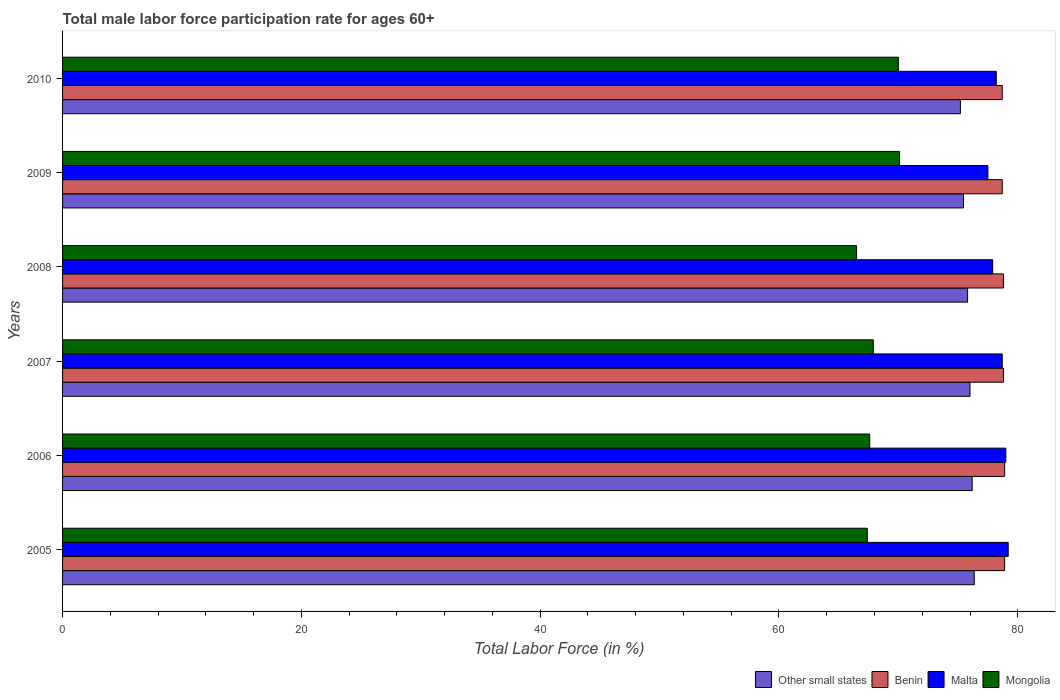How many groups of bars are there?
Provide a succinct answer. 6. Are the number of bars per tick equal to the number of legend labels?
Provide a short and direct response. Yes. What is the label of the 2nd group of bars from the top?
Your response must be concise. 2009. What is the male labor force participation rate in Malta in 2006?
Give a very brief answer. 79. Across all years, what is the maximum male labor force participation rate in Other small states?
Provide a succinct answer. 76.35. Across all years, what is the minimum male labor force participation rate in Other small states?
Provide a short and direct response. 75.2. What is the total male labor force participation rate in Mongolia in the graph?
Offer a terse response. 409.5. What is the difference between the male labor force participation rate in Benin in 2006 and that in 2010?
Offer a terse response. 0.2. What is the difference between the male labor force participation rate in Malta in 2006 and the male labor force participation rate in Mongolia in 2009?
Your answer should be very brief. 8.9. What is the average male labor force participation rate in Other small states per year?
Provide a succinct answer. 75.83. In the year 2005, what is the difference between the male labor force participation rate in Benin and male labor force participation rate in Malta?
Provide a succinct answer. -0.3. What is the ratio of the male labor force participation rate in Other small states in 2009 to that in 2010?
Make the answer very short. 1. Is the male labor force participation rate in Mongolia in 2007 less than that in 2010?
Offer a terse response. Yes. What is the difference between the highest and the second highest male labor force participation rate in Benin?
Offer a very short reply. 0. What is the difference between the highest and the lowest male labor force participation rate in Other small states?
Offer a terse response. 1.16. In how many years, is the male labor force participation rate in Mongolia greater than the average male labor force participation rate in Mongolia taken over all years?
Give a very brief answer. 2. Is the sum of the male labor force participation rate in Other small states in 2005 and 2010 greater than the maximum male labor force participation rate in Benin across all years?
Offer a terse response. Yes. What does the 2nd bar from the top in 2005 represents?
Ensure brevity in your answer.  Malta. What does the 1st bar from the bottom in 2010 represents?
Your answer should be compact. Other small states. Is it the case that in every year, the sum of the male labor force participation rate in Mongolia and male labor force participation rate in Other small states is greater than the male labor force participation rate in Malta?
Provide a short and direct response. Yes. Are all the bars in the graph horizontal?
Keep it short and to the point. Yes. What is the difference between two consecutive major ticks on the X-axis?
Your answer should be compact. 20. How many legend labels are there?
Your response must be concise. 4. What is the title of the graph?
Give a very brief answer. Total male labor force participation rate for ages 60+. Does "Romania" appear as one of the legend labels in the graph?
Offer a very short reply. No. What is the label or title of the Y-axis?
Your answer should be compact. Years. What is the Total Labor Force (in %) of Other small states in 2005?
Your answer should be very brief. 76.35. What is the Total Labor Force (in %) in Benin in 2005?
Offer a terse response. 78.9. What is the Total Labor Force (in %) in Malta in 2005?
Make the answer very short. 79.2. What is the Total Labor Force (in %) in Mongolia in 2005?
Offer a terse response. 67.4. What is the Total Labor Force (in %) in Other small states in 2006?
Make the answer very short. 76.18. What is the Total Labor Force (in %) of Benin in 2006?
Your response must be concise. 78.9. What is the Total Labor Force (in %) of Malta in 2006?
Offer a very short reply. 79. What is the Total Labor Force (in %) in Mongolia in 2006?
Your answer should be compact. 67.6. What is the Total Labor Force (in %) of Other small states in 2007?
Provide a succinct answer. 76. What is the Total Labor Force (in %) of Benin in 2007?
Offer a very short reply. 78.8. What is the Total Labor Force (in %) in Malta in 2007?
Your answer should be very brief. 78.7. What is the Total Labor Force (in %) of Mongolia in 2007?
Ensure brevity in your answer.  67.9. What is the Total Labor Force (in %) of Other small states in 2008?
Ensure brevity in your answer.  75.8. What is the Total Labor Force (in %) in Benin in 2008?
Offer a very short reply. 78.8. What is the Total Labor Force (in %) in Malta in 2008?
Offer a very short reply. 77.9. What is the Total Labor Force (in %) of Mongolia in 2008?
Ensure brevity in your answer.  66.5. What is the Total Labor Force (in %) of Other small states in 2009?
Offer a terse response. 75.46. What is the Total Labor Force (in %) of Benin in 2009?
Your answer should be very brief. 78.7. What is the Total Labor Force (in %) in Malta in 2009?
Your answer should be compact. 77.5. What is the Total Labor Force (in %) of Mongolia in 2009?
Ensure brevity in your answer.  70.1. What is the Total Labor Force (in %) of Other small states in 2010?
Your response must be concise. 75.2. What is the Total Labor Force (in %) of Benin in 2010?
Provide a short and direct response. 78.7. What is the Total Labor Force (in %) of Malta in 2010?
Your answer should be very brief. 78.2. Across all years, what is the maximum Total Labor Force (in %) of Other small states?
Provide a short and direct response. 76.35. Across all years, what is the maximum Total Labor Force (in %) of Benin?
Offer a very short reply. 78.9. Across all years, what is the maximum Total Labor Force (in %) of Malta?
Ensure brevity in your answer.  79.2. Across all years, what is the maximum Total Labor Force (in %) of Mongolia?
Make the answer very short. 70.1. Across all years, what is the minimum Total Labor Force (in %) in Other small states?
Provide a short and direct response. 75.2. Across all years, what is the minimum Total Labor Force (in %) in Benin?
Give a very brief answer. 78.7. Across all years, what is the minimum Total Labor Force (in %) of Malta?
Provide a succinct answer. 77.5. Across all years, what is the minimum Total Labor Force (in %) of Mongolia?
Make the answer very short. 66.5. What is the total Total Labor Force (in %) of Other small states in the graph?
Provide a short and direct response. 454.99. What is the total Total Labor Force (in %) of Benin in the graph?
Make the answer very short. 472.8. What is the total Total Labor Force (in %) of Malta in the graph?
Make the answer very short. 470.5. What is the total Total Labor Force (in %) in Mongolia in the graph?
Keep it short and to the point. 409.5. What is the difference between the Total Labor Force (in %) of Other small states in 2005 and that in 2006?
Offer a terse response. 0.17. What is the difference between the Total Labor Force (in %) in Benin in 2005 and that in 2006?
Keep it short and to the point. 0. What is the difference between the Total Labor Force (in %) in Malta in 2005 and that in 2006?
Keep it short and to the point. 0.2. What is the difference between the Total Labor Force (in %) in Other small states in 2005 and that in 2007?
Offer a very short reply. 0.35. What is the difference between the Total Labor Force (in %) in Benin in 2005 and that in 2007?
Give a very brief answer. 0.1. What is the difference between the Total Labor Force (in %) of Mongolia in 2005 and that in 2007?
Provide a succinct answer. -0.5. What is the difference between the Total Labor Force (in %) in Other small states in 2005 and that in 2008?
Offer a very short reply. 0.56. What is the difference between the Total Labor Force (in %) of Mongolia in 2005 and that in 2008?
Give a very brief answer. 0.9. What is the difference between the Total Labor Force (in %) of Other small states in 2005 and that in 2009?
Make the answer very short. 0.9. What is the difference between the Total Labor Force (in %) in Mongolia in 2005 and that in 2009?
Give a very brief answer. -2.7. What is the difference between the Total Labor Force (in %) in Other small states in 2005 and that in 2010?
Give a very brief answer. 1.16. What is the difference between the Total Labor Force (in %) of Benin in 2005 and that in 2010?
Make the answer very short. 0.2. What is the difference between the Total Labor Force (in %) of Malta in 2005 and that in 2010?
Provide a short and direct response. 1. What is the difference between the Total Labor Force (in %) of Other small states in 2006 and that in 2007?
Make the answer very short. 0.18. What is the difference between the Total Labor Force (in %) in Benin in 2006 and that in 2007?
Give a very brief answer. 0.1. What is the difference between the Total Labor Force (in %) in Mongolia in 2006 and that in 2007?
Keep it short and to the point. -0.3. What is the difference between the Total Labor Force (in %) in Other small states in 2006 and that in 2008?
Make the answer very short. 0.38. What is the difference between the Total Labor Force (in %) in Malta in 2006 and that in 2008?
Your response must be concise. 1.1. What is the difference between the Total Labor Force (in %) of Other small states in 2006 and that in 2009?
Keep it short and to the point. 0.73. What is the difference between the Total Labor Force (in %) in Benin in 2006 and that in 2009?
Provide a succinct answer. 0.2. What is the difference between the Total Labor Force (in %) of Mongolia in 2006 and that in 2009?
Provide a short and direct response. -2.5. What is the difference between the Total Labor Force (in %) in Other small states in 2006 and that in 2010?
Provide a short and direct response. 0.99. What is the difference between the Total Labor Force (in %) in Benin in 2006 and that in 2010?
Your answer should be very brief. 0.2. What is the difference between the Total Labor Force (in %) in Malta in 2006 and that in 2010?
Give a very brief answer. 0.8. What is the difference between the Total Labor Force (in %) of Other small states in 2007 and that in 2008?
Keep it short and to the point. 0.2. What is the difference between the Total Labor Force (in %) in Benin in 2007 and that in 2008?
Your answer should be compact. 0. What is the difference between the Total Labor Force (in %) in Malta in 2007 and that in 2008?
Offer a very short reply. 0.8. What is the difference between the Total Labor Force (in %) of Mongolia in 2007 and that in 2008?
Your answer should be compact. 1.4. What is the difference between the Total Labor Force (in %) in Other small states in 2007 and that in 2009?
Your answer should be compact. 0.54. What is the difference between the Total Labor Force (in %) in Mongolia in 2007 and that in 2009?
Your answer should be very brief. -2.2. What is the difference between the Total Labor Force (in %) in Other small states in 2007 and that in 2010?
Provide a succinct answer. 0.8. What is the difference between the Total Labor Force (in %) in Benin in 2007 and that in 2010?
Provide a short and direct response. 0.1. What is the difference between the Total Labor Force (in %) in Mongolia in 2007 and that in 2010?
Your answer should be very brief. -2.1. What is the difference between the Total Labor Force (in %) in Other small states in 2008 and that in 2009?
Offer a terse response. 0.34. What is the difference between the Total Labor Force (in %) of Benin in 2008 and that in 2009?
Your answer should be very brief. 0.1. What is the difference between the Total Labor Force (in %) in Malta in 2008 and that in 2009?
Your answer should be very brief. 0.4. What is the difference between the Total Labor Force (in %) in Mongolia in 2008 and that in 2009?
Your answer should be compact. -3.6. What is the difference between the Total Labor Force (in %) in Other small states in 2008 and that in 2010?
Offer a very short reply. 0.6. What is the difference between the Total Labor Force (in %) in Benin in 2008 and that in 2010?
Make the answer very short. 0.1. What is the difference between the Total Labor Force (in %) in Mongolia in 2008 and that in 2010?
Your response must be concise. -3.5. What is the difference between the Total Labor Force (in %) in Other small states in 2009 and that in 2010?
Offer a very short reply. 0.26. What is the difference between the Total Labor Force (in %) of Benin in 2009 and that in 2010?
Keep it short and to the point. 0. What is the difference between the Total Labor Force (in %) in Malta in 2009 and that in 2010?
Provide a succinct answer. -0.7. What is the difference between the Total Labor Force (in %) of Other small states in 2005 and the Total Labor Force (in %) of Benin in 2006?
Provide a short and direct response. -2.55. What is the difference between the Total Labor Force (in %) in Other small states in 2005 and the Total Labor Force (in %) in Malta in 2006?
Your response must be concise. -2.65. What is the difference between the Total Labor Force (in %) in Other small states in 2005 and the Total Labor Force (in %) in Mongolia in 2006?
Make the answer very short. 8.75. What is the difference between the Total Labor Force (in %) in Benin in 2005 and the Total Labor Force (in %) in Malta in 2006?
Keep it short and to the point. -0.1. What is the difference between the Total Labor Force (in %) in Benin in 2005 and the Total Labor Force (in %) in Mongolia in 2006?
Provide a succinct answer. 11.3. What is the difference between the Total Labor Force (in %) in Malta in 2005 and the Total Labor Force (in %) in Mongolia in 2006?
Your answer should be very brief. 11.6. What is the difference between the Total Labor Force (in %) of Other small states in 2005 and the Total Labor Force (in %) of Benin in 2007?
Your response must be concise. -2.45. What is the difference between the Total Labor Force (in %) of Other small states in 2005 and the Total Labor Force (in %) of Malta in 2007?
Provide a short and direct response. -2.35. What is the difference between the Total Labor Force (in %) in Other small states in 2005 and the Total Labor Force (in %) in Mongolia in 2007?
Offer a terse response. 8.45. What is the difference between the Total Labor Force (in %) in Benin in 2005 and the Total Labor Force (in %) in Malta in 2007?
Offer a very short reply. 0.2. What is the difference between the Total Labor Force (in %) in Other small states in 2005 and the Total Labor Force (in %) in Benin in 2008?
Your answer should be compact. -2.45. What is the difference between the Total Labor Force (in %) of Other small states in 2005 and the Total Labor Force (in %) of Malta in 2008?
Provide a succinct answer. -1.55. What is the difference between the Total Labor Force (in %) of Other small states in 2005 and the Total Labor Force (in %) of Mongolia in 2008?
Provide a succinct answer. 9.85. What is the difference between the Total Labor Force (in %) in Benin in 2005 and the Total Labor Force (in %) in Malta in 2008?
Provide a succinct answer. 1. What is the difference between the Total Labor Force (in %) in Malta in 2005 and the Total Labor Force (in %) in Mongolia in 2008?
Provide a succinct answer. 12.7. What is the difference between the Total Labor Force (in %) of Other small states in 2005 and the Total Labor Force (in %) of Benin in 2009?
Your response must be concise. -2.35. What is the difference between the Total Labor Force (in %) in Other small states in 2005 and the Total Labor Force (in %) in Malta in 2009?
Make the answer very short. -1.15. What is the difference between the Total Labor Force (in %) of Other small states in 2005 and the Total Labor Force (in %) of Mongolia in 2009?
Provide a succinct answer. 6.25. What is the difference between the Total Labor Force (in %) of Benin in 2005 and the Total Labor Force (in %) of Malta in 2009?
Ensure brevity in your answer.  1.4. What is the difference between the Total Labor Force (in %) of Other small states in 2005 and the Total Labor Force (in %) of Benin in 2010?
Your answer should be very brief. -2.35. What is the difference between the Total Labor Force (in %) in Other small states in 2005 and the Total Labor Force (in %) in Malta in 2010?
Offer a very short reply. -1.85. What is the difference between the Total Labor Force (in %) of Other small states in 2005 and the Total Labor Force (in %) of Mongolia in 2010?
Keep it short and to the point. 6.35. What is the difference between the Total Labor Force (in %) in Benin in 2005 and the Total Labor Force (in %) in Malta in 2010?
Make the answer very short. 0.7. What is the difference between the Total Labor Force (in %) of Benin in 2005 and the Total Labor Force (in %) of Mongolia in 2010?
Provide a succinct answer. 8.9. What is the difference between the Total Labor Force (in %) in Other small states in 2006 and the Total Labor Force (in %) in Benin in 2007?
Offer a terse response. -2.62. What is the difference between the Total Labor Force (in %) of Other small states in 2006 and the Total Labor Force (in %) of Malta in 2007?
Offer a very short reply. -2.52. What is the difference between the Total Labor Force (in %) in Other small states in 2006 and the Total Labor Force (in %) in Mongolia in 2007?
Your answer should be very brief. 8.28. What is the difference between the Total Labor Force (in %) in Benin in 2006 and the Total Labor Force (in %) in Malta in 2007?
Offer a terse response. 0.2. What is the difference between the Total Labor Force (in %) in Malta in 2006 and the Total Labor Force (in %) in Mongolia in 2007?
Your answer should be very brief. 11.1. What is the difference between the Total Labor Force (in %) of Other small states in 2006 and the Total Labor Force (in %) of Benin in 2008?
Provide a succinct answer. -2.62. What is the difference between the Total Labor Force (in %) in Other small states in 2006 and the Total Labor Force (in %) in Malta in 2008?
Keep it short and to the point. -1.72. What is the difference between the Total Labor Force (in %) in Other small states in 2006 and the Total Labor Force (in %) in Mongolia in 2008?
Make the answer very short. 9.68. What is the difference between the Total Labor Force (in %) of Benin in 2006 and the Total Labor Force (in %) of Malta in 2008?
Ensure brevity in your answer.  1. What is the difference between the Total Labor Force (in %) of Other small states in 2006 and the Total Labor Force (in %) of Benin in 2009?
Give a very brief answer. -2.52. What is the difference between the Total Labor Force (in %) of Other small states in 2006 and the Total Labor Force (in %) of Malta in 2009?
Ensure brevity in your answer.  -1.32. What is the difference between the Total Labor Force (in %) of Other small states in 2006 and the Total Labor Force (in %) of Mongolia in 2009?
Your response must be concise. 6.08. What is the difference between the Total Labor Force (in %) in Benin in 2006 and the Total Labor Force (in %) in Malta in 2009?
Make the answer very short. 1.4. What is the difference between the Total Labor Force (in %) in Benin in 2006 and the Total Labor Force (in %) in Mongolia in 2009?
Your response must be concise. 8.8. What is the difference between the Total Labor Force (in %) of Other small states in 2006 and the Total Labor Force (in %) of Benin in 2010?
Ensure brevity in your answer.  -2.52. What is the difference between the Total Labor Force (in %) of Other small states in 2006 and the Total Labor Force (in %) of Malta in 2010?
Give a very brief answer. -2.02. What is the difference between the Total Labor Force (in %) in Other small states in 2006 and the Total Labor Force (in %) in Mongolia in 2010?
Provide a succinct answer. 6.18. What is the difference between the Total Labor Force (in %) in Malta in 2006 and the Total Labor Force (in %) in Mongolia in 2010?
Your answer should be very brief. 9. What is the difference between the Total Labor Force (in %) in Other small states in 2007 and the Total Labor Force (in %) in Benin in 2008?
Offer a terse response. -2.8. What is the difference between the Total Labor Force (in %) of Other small states in 2007 and the Total Labor Force (in %) of Malta in 2008?
Offer a terse response. -1.9. What is the difference between the Total Labor Force (in %) of Other small states in 2007 and the Total Labor Force (in %) of Mongolia in 2008?
Offer a terse response. 9.5. What is the difference between the Total Labor Force (in %) in Benin in 2007 and the Total Labor Force (in %) in Malta in 2008?
Your response must be concise. 0.9. What is the difference between the Total Labor Force (in %) in Other small states in 2007 and the Total Labor Force (in %) in Benin in 2009?
Provide a short and direct response. -2.7. What is the difference between the Total Labor Force (in %) of Other small states in 2007 and the Total Labor Force (in %) of Malta in 2009?
Your response must be concise. -1.5. What is the difference between the Total Labor Force (in %) in Other small states in 2007 and the Total Labor Force (in %) in Mongolia in 2009?
Your answer should be compact. 5.9. What is the difference between the Total Labor Force (in %) of Benin in 2007 and the Total Labor Force (in %) of Malta in 2009?
Provide a short and direct response. 1.3. What is the difference between the Total Labor Force (in %) in Malta in 2007 and the Total Labor Force (in %) in Mongolia in 2009?
Your response must be concise. 8.6. What is the difference between the Total Labor Force (in %) in Other small states in 2007 and the Total Labor Force (in %) in Benin in 2010?
Make the answer very short. -2.7. What is the difference between the Total Labor Force (in %) in Other small states in 2007 and the Total Labor Force (in %) in Malta in 2010?
Offer a very short reply. -2.2. What is the difference between the Total Labor Force (in %) of Other small states in 2007 and the Total Labor Force (in %) of Mongolia in 2010?
Provide a short and direct response. 6. What is the difference between the Total Labor Force (in %) of Other small states in 2008 and the Total Labor Force (in %) of Benin in 2009?
Keep it short and to the point. -2.9. What is the difference between the Total Labor Force (in %) of Other small states in 2008 and the Total Labor Force (in %) of Malta in 2009?
Make the answer very short. -1.7. What is the difference between the Total Labor Force (in %) of Other small states in 2008 and the Total Labor Force (in %) of Mongolia in 2009?
Provide a succinct answer. 5.7. What is the difference between the Total Labor Force (in %) of Benin in 2008 and the Total Labor Force (in %) of Mongolia in 2009?
Give a very brief answer. 8.7. What is the difference between the Total Labor Force (in %) in Other small states in 2008 and the Total Labor Force (in %) in Benin in 2010?
Provide a short and direct response. -2.9. What is the difference between the Total Labor Force (in %) in Other small states in 2008 and the Total Labor Force (in %) in Malta in 2010?
Keep it short and to the point. -2.4. What is the difference between the Total Labor Force (in %) of Other small states in 2008 and the Total Labor Force (in %) of Mongolia in 2010?
Keep it short and to the point. 5.8. What is the difference between the Total Labor Force (in %) in Benin in 2008 and the Total Labor Force (in %) in Malta in 2010?
Offer a very short reply. 0.6. What is the difference between the Total Labor Force (in %) of Benin in 2008 and the Total Labor Force (in %) of Mongolia in 2010?
Your answer should be compact. 8.8. What is the difference between the Total Labor Force (in %) of Other small states in 2009 and the Total Labor Force (in %) of Benin in 2010?
Provide a succinct answer. -3.24. What is the difference between the Total Labor Force (in %) in Other small states in 2009 and the Total Labor Force (in %) in Malta in 2010?
Give a very brief answer. -2.74. What is the difference between the Total Labor Force (in %) of Other small states in 2009 and the Total Labor Force (in %) of Mongolia in 2010?
Your answer should be compact. 5.46. What is the difference between the Total Labor Force (in %) in Benin in 2009 and the Total Labor Force (in %) in Malta in 2010?
Keep it short and to the point. 0.5. What is the difference between the Total Labor Force (in %) in Benin in 2009 and the Total Labor Force (in %) in Mongolia in 2010?
Offer a terse response. 8.7. What is the difference between the Total Labor Force (in %) in Malta in 2009 and the Total Labor Force (in %) in Mongolia in 2010?
Make the answer very short. 7.5. What is the average Total Labor Force (in %) in Other small states per year?
Provide a succinct answer. 75.83. What is the average Total Labor Force (in %) of Benin per year?
Give a very brief answer. 78.8. What is the average Total Labor Force (in %) in Malta per year?
Give a very brief answer. 78.42. What is the average Total Labor Force (in %) in Mongolia per year?
Provide a short and direct response. 68.25. In the year 2005, what is the difference between the Total Labor Force (in %) in Other small states and Total Labor Force (in %) in Benin?
Your answer should be very brief. -2.55. In the year 2005, what is the difference between the Total Labor Force (in %) in Other small states and Total Labor Force (in %) in Malta?
Keep it short and to the point. -2.85. In the year 2005, what is the difference between the Total Labor Force (in %) in Other small states and Total Labor Force (in %) in Mongolia?
Provide a short and direct response. 8.95. In the year 2005, what is the difference between the Total Labor Force (in %) in Malta and Total Labor Force (in %) in Mongolia?
Offer a terse response. 11.8. In the year 2006, what is the difference between the Total Labor Force (in %) in Other small states and Total Labor Force (in %) in Benin?
Give a very brief answer. -2.72. In the year 2006, what is the difference between the Total Labor Force (in %) of Other small states and Total Labor Force (in %) of Malta?
Provide a short and direct response. -2.82. In the year 2006, what is the difference between the Total Labor Force (in %) of Other small states and Total Labor Force (in %) of Mongolia?
Give a very brief answer. 8.58. In the year 2006, what is the difference between the Total Labor Force (in %) in Benin and Total Labor Force (in %) in Mongolia?
Offer a very short reply. 11.3. In the year 2006, what is the difference between the Total Labor Force (in %) in Malta and Total Labor Force (in %) in Mongolia?
Ensure brevity in your answer.  11.4. In the year 2007, what is the difference between the Total Labor Force (in %) in Other small states and Total Labor Force (in %) in Benin?
Give a very brief answer. -2.8. In the year 2007, what is the difference between the Total Labor Force (in %) in Other small states and Total Labor Force (in %) in Malta?
Give a very brief answer. -2.7. In the year 2007, what is the difference between the Total Labor Force (in %) in Other small states and Total Labor Force (in %) in Mongolia?
Your answer should be very brief. 8.1. In the year 2007, what is the difference between the Total Labor Force (in %) in Benin and Total Labor Force (in %) in Mongolia?
Your answer should be compact. 10.9. In the year 2007, what is the difference between the Total Labor Force (in %) in Malta and Total Labor Force (in %) in Mongolia?
Offer a very short reply. 10.8. In the year 2008, what is the difference between the Total Labor Force (in %) in Other small states and Total Labor Force (in %) in Benin?
Provide a short and direct response. -3. In the year 2008, what is the difference between the Total Labor Force (in %) of Other small states and Total Labor Force (in %) of Malta?
Ensure brevity in your answer.  -2.1. In the year 2008, what is the difference between the Total Labor Force (in %) of Other small states and Total Labor Force (in %) of Mongolia?
Ensure brevity in your answer.  9.3. In the year 2008, what is the difference between the Total Labor Force (in %) in Benin and Total Labor Force (in %) in Malta?
Provide a short and direct response. 0.9. In the year 2008, what is the difference between the Total Labor Force (in %) in Benin and Total Labor Force (in %) in Mongolia?
Give a very brief answer. 12.3. In the year 2009, what is the difference between the Total Labor Force (in %) of Other small states and Total Labor Force (in %) of Benin?
Give a very brief answer. -3.24. In the year 2009, what is the difference between the Total Labor Force (in %) of Other small states and Total Labor Force (in %) of Malta?
Your answer should be compact. -2.04. In the year 2009, what is the difference between the Total Labor Force (in %) of Other small states and Total Labor Force (in %) of Mongolia?
Ensure brevity in your answer.  5.36. In the year 2009, what is the difference between the Total Labor Force (in %) of Benin and Total Labor Force (in %) of Mongolia?
Offer a terse response. 8.6. In the year 2009, what is the difference between the Total Labor Force (in %) of Malta and Total Labor Force (in %) of Mongolia?
Your answer should be very brief. 7.4. In the year 2010, what is the difference between the Total Labor Force (in %) in Other small states and Total Labor Force (in %) in Benin?
Give a very brief answer. -3.5. In the year 2010, what is the difference between the Total Labor Force (in %) of Other small states and Total Labor Force (in %) of Malta?
Ensure brevity in your answer.  -3. In the year 2010, what is the difference between the Total Labor Force (in %) in Other small states and Total Labor Force (in %) in Mongolia?
Provide a short and direct response. 5.2. In the year 2010, what is the difference between the Total Labor Force (in %) in Malta and Total Labor Force (in %) in Mongolia?
Ensure brevity in your answer.  8.2. What is the ratio of the Total Labor Force (in %) of Other small states in 2005 to that in 2006?
Keep it short and to the point. 1. What is the ratio of the Total Labor Force (in %) of Mongolia in 2005 to that in 2006?
Offer a very short reply. 1. What is the ratio of the Total Labor Force (in %) of Other small states in 2005 to that in 2007?
Ensure brevity in your answer.  1. What is the ratio of the Total Labor Force (in %) of Benin in 2005 to that in 2007?
Your response must be concise. 1. What is the ratio of the Total Labor Force (in %) in Malta in 2005 to that in 2007?
Your answer should be compact. 1.01. What is the ratio of the Total Labor Force (in %) of Other small states in 2005 to that in 2008?
Your answer should be very brief. 1.01. What is the ratio of the Total Labor Force (in %) in Benin in 2005 to that in 2008?
Your response must be concise. 1. What is the ratio of the Total Labor Force (in %) of Malta in 2005 to that in 2008?
Make the answer very short. 1.02. What is the ratio of the Total Labor Force (in %) of Mongolia in 2005 to that in 2008?
Your answer should be compact. 1.01. What is the ratio of the Total Labor Force (in %) in Other small states in 2005 to that in 2009?
Give a very brief answer. 1.01. What is the ratio of the Total Labor Force (in %) of Benin in 2005 to that in 2009?
Keep it short and to the point. 1. What is the ratio of the Total Labor Force (in %) of Malta in 2005 to that in 2009?
Ensure brevity in your answer.  1.02. What is the ratio of the Total Labor Force (in %) of Mongolia in 2005 to that in 2009?
Offer a very short reply. 0.96. What is the ratio of the Total Labor Force (in %) in Other small states in 2005 to that in 2010?
Provide a succinct answer. 1.02. What is the ratio of the Total Labor Force (in %) in Malta in 2005 to that in 2010?
Offer a terse response. 1.01. What is the ratio of the Total Labor Force (in %) of Mongolia in 2005 to that in 2010?
Keep it short and to the point. 0.96. What is the ratio of the Total Labor Force (in %) of Other small states in 2006 to that in 2007?
Give a very brief answer. 1. What is the ratio of the Total Labor Force (in %) in Other small states in 2006 to that in 2008?
Offer a very short reply. 1. What is the ratio of the Total Labor Force (in %) of Benin in 2006 to that in 2008?
Your answer should be compact. 1. What is the ratio of the Total Labor Force (in %) in Malta in 2006 to that in 2008?
Your answer should be compact. 1.01. What is the ratio of the Total Labor Force (in %) of Mongolia in 2006 to that in 2008?
Make the answer very short. 1.02. What is the ratio of the Total Labor Force (in %) of Other small states in 2006 to that in 2009?
Keep it short and to the point. 1.01. What is the ratio of the Total Labor Force (in %) in Benin in 2006 to that in 2009?
Your response must be concise. 1. What is the ratio of the Total Labor Force (in %) of Malta in 2006 to that in 2009?
Provide a short and direct response. 1.02. What is the ratio of the Total Labor Force (in %) in Other small states in 2006 to that in 2010?
Make the answer very short. 1.01. What is the ratio of the Total Labor Force (in %) in Malta in 2006 to that in 2010?
Keep it short and to the point. 1.01. What is the ratio of the Total Labor Force (in %) of Mongolia in 2006 to that in 2010?
Ensure brevity in your answer.  0.97. What is the ratio of the Total Labor Force (in %) in Malta in 2007 to that in 2008?
Offer a terse response. 1.01. What is the ratio of the Total Labor Force (in %) of Mongolia in 2007 to that in 2008?
Offer a very short reply. 1.02. What is the ratio of the Total Labor Force (in %) of Benin in 2007 to that in 2009?
Offer a very short reply. 1. What is the ratio of the Total Labor Force (in %) in Malta in 2007 to that in 2009?
Provide a short and direct response. 1.02. What is the ratio of the Total Labor Force (in %) of Mongolia in 2007 to that in 2009?
Your response must be concise. 0.97. What is the ratio of the Total Labor Force (in %) in Other small states in 2007 to that in 2010?
Provide a succinct answer. 1.01. What is the ratio of the Total Labor Force (in %) of Benin in 2007 to that in 2010?
Provide a succinct answer. 1. What is the ratio of the Total Labor Force (in %) of Malta in 2007 to that in 2010?
Keep it short and to the point. 1.01. What is the ratio of the Total Labor Force (in %) of Other small states in 2008 to that in 2009?
Ensure brevity in your answer.  1. What is the ratio of the Total Labor Force (in %) of Benin in 2008 to that in 2009?
Ensure brevity in your answer.  1. What is the ratio of the Total Labor Force (in %) of Malta in 2008 to that in 2009?
Ensure brevity in your answer.  1.01. What is the ratio of the Total Labor Force (in %) in Mongolia in 2008 to that in 2009?
Make the answer very short. 0.95. What is the ratio of the Total Labor Force (in %) in Benin in 2008 to that in 2010?
Give a very brief answer. 1. What is the ratio of the Total Labor Force (in %) of Mongolia in 2008 to that in 2010?
Provide a succinct answer. 0.95. What is the ratio of the Total Labor Force (in %) in Malta in 2009 to that in 2010?
Offer a very short reply. 0.99. What is the ratio of the Total Labor Force (in %) of Mongolia in 2009 to that in 2010?
Your answer should be compact. 1. What is the difference between the highest and the second highest Total Labor Force (in %) in Other small states?
Your response must be concise. 0.17. What is the difference between the highest and the second highest Total Labor Force (in %) in Malta?
Your response must be concise. 0.2. What is the difference between the highest and the lowest Total Labor Force (in %) of Other small states?
Give a very brief answer. 1.16. What is the difference between the highest and the lowest Total Labor Force (in %) of Malta?
Keep it short and to the point. 1.7. What is the difference between the highest and the lowest Total Labor Force (in %) of Mongolia?
Keep it short and to the point. 3.6. 